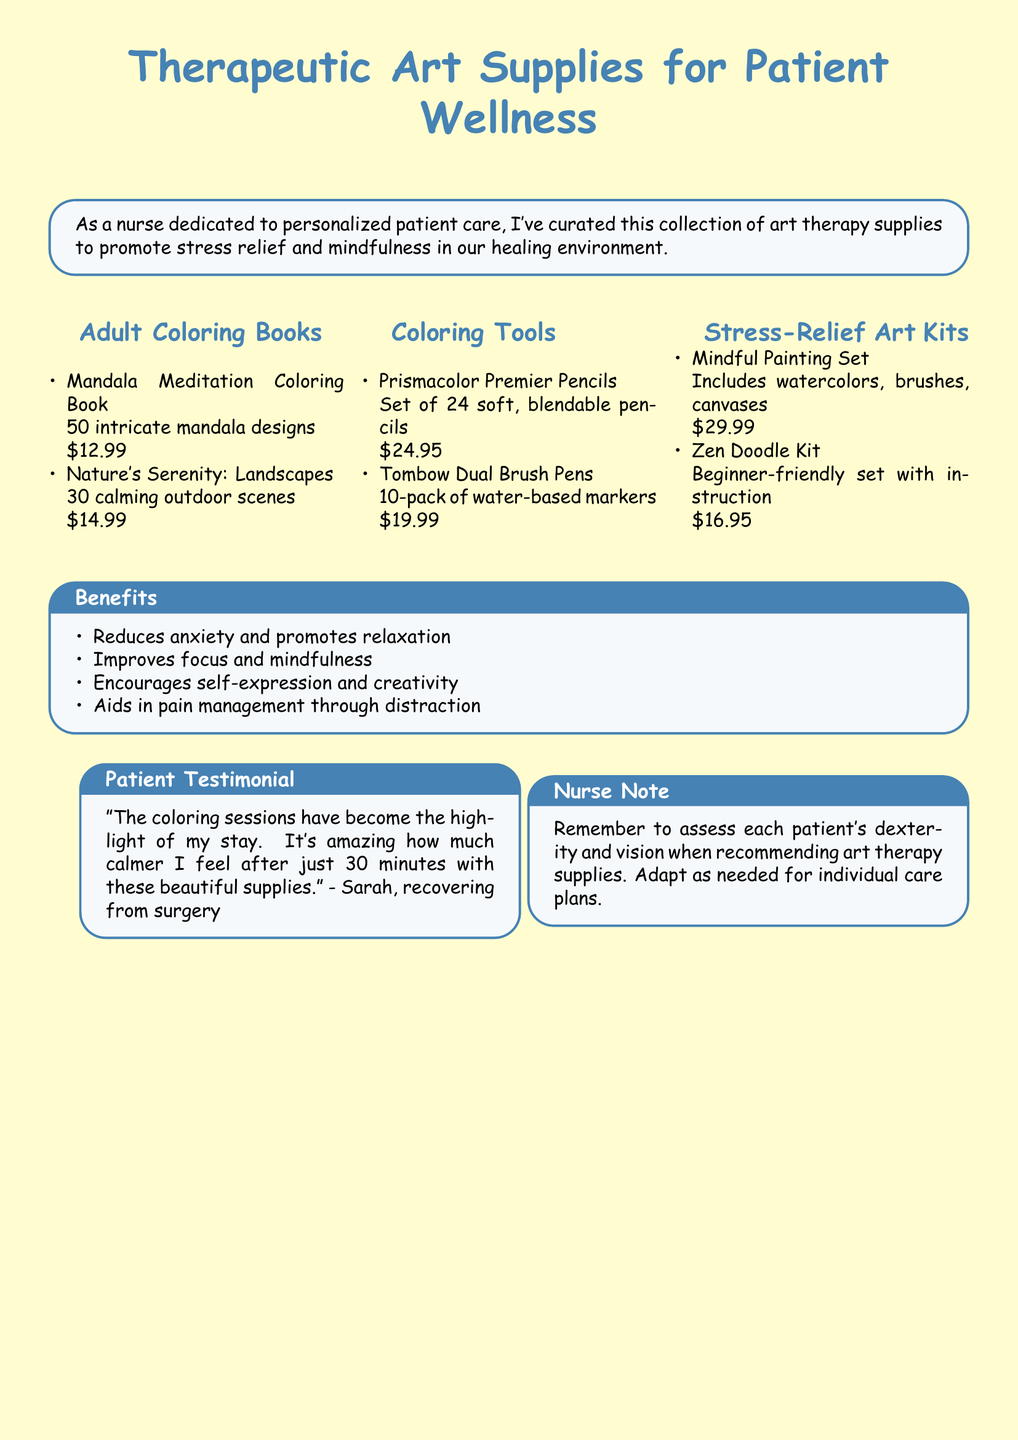What is the title of the first coloring book? The title of the first coloring book is mentioned in the "Adult Coloring Books" section of the document.
Answer: Mandala Meditation Coloring Book How much do Prismacolor Premier Pencils cost? The cost of Prismacolor Premier Pencils is provided in the "Coloring Tools" section.
Answer: $24.95 What is included in the Mindful Painting Set? The contents of the Mindful Painting Set are listed in the "Stress-Relief Art Kits" section.
Answer: watercolors, brushes, canvases How many intricate designs are in Nature's Serenity: Landscapes? The number of designs is specified in the description of the "Nature's Serenity: Landscapes" coloring book.
Answer: 30 calming outdoor scenes What is one of the benefits of using art therapy supplies? The benefits are listed in a section titled "Benefits" in the document.
Answer: Reduces anxiety Who provided a testimonial about the coloring sessions? The testimonial section identifies a patient who expressed their feelings about the coloring sessions.
Answer: Sarah What is the price of the Zen Doodle Kit? The price of the Zen Doodle Kit is found in the "Stress-Relief Art Kits" section.
Answer: $16.95 What type of markers are included in the Tombow Dual Brush Pens? The type of markers is mentioned in the "Coloring Tools" section of the document.
Answer: water-based markers What should be considered when recommending art therapy supplies? The "Nurse Note" section highlights an important consideration for nurses.
Answer: dexterity and vision 